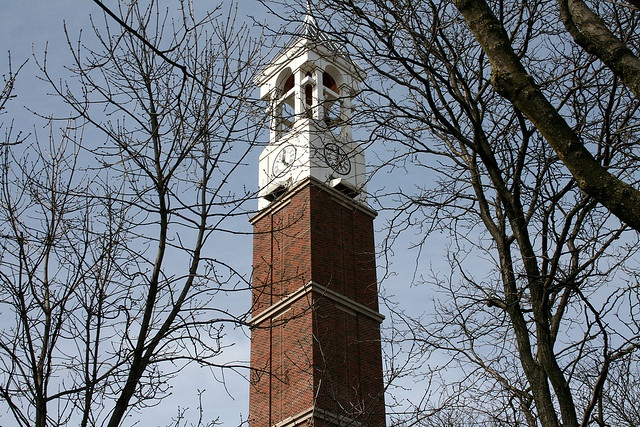Describe the objects in this image and their specific colors. I can see clock in gray, white, darkgray, and black tones and clock in gray, black, and darkgray tones in this image. 